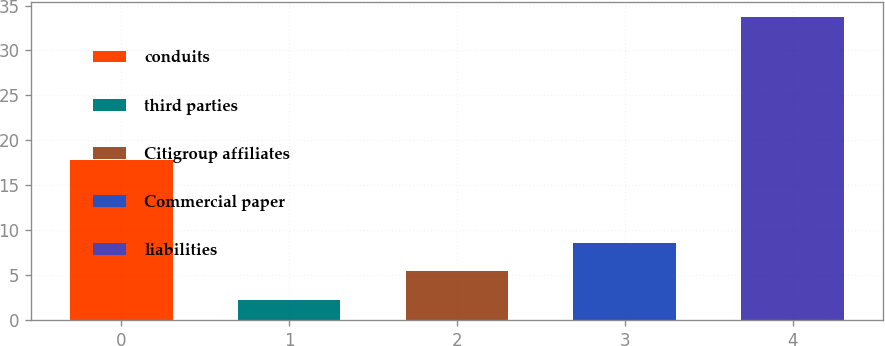<chart> <loc_0><loc_0><loc_500><loc_500><bar_chart><fcel>conduits<fcel>third parties<fcel>Citigroup affiliates<fcel>Commercial paper<fcel>liabilities<nl><fcel>17.8<fcel>2.3<fcel>5.44<fcel>8.58<fcel>33.7<nl></chart> 